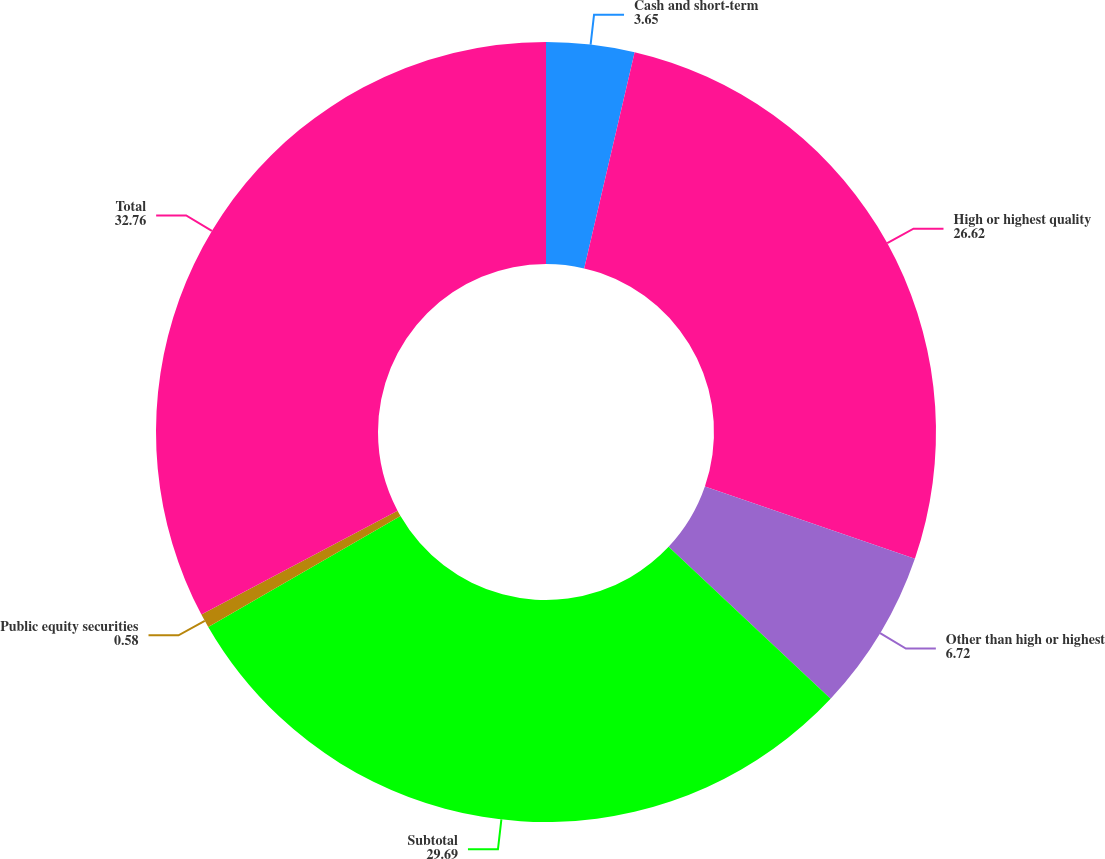Convert chart. <chart><loc_0><loc_0><loc_500><loc_500><pie_chart><fcel>Cash and short-term<fcel>High or highest quality<fcel>Other than high or highest<fcel>Subtotal<fcel>Public equity securities<fcel>Total<nl><fcel>3.65%<fcel>26.62%<fcel>6.72%<fcel>29.69%<fcel>0.58%<fcel>32.76%<nl></chart> 